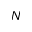Convert formula to latex. <formula><loc_0><loc_0><loc_500><loc_500>N</formula> 